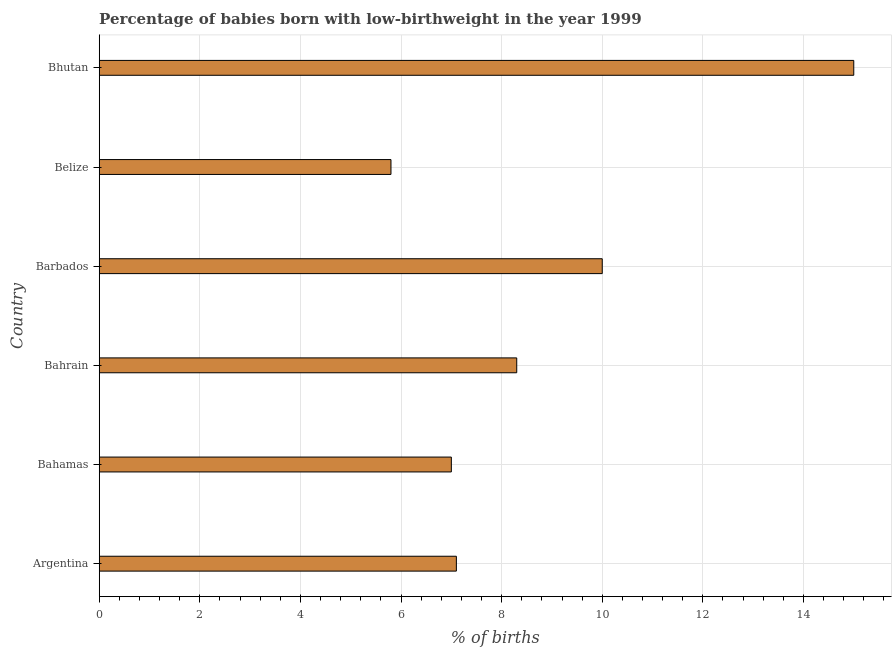Does the graph contain any zero values?
Make the answer very short. No. Does the graph contain grids?
Give a very brief answer. Yes. What is the title of the graph?
Make the answer very short. Percentage of babies born with low-birthweight in the year 1999. What is the label or title of the X-axis?
Offer a very short reply. % of births. What is the label or title of the Y-axis?
Make the answer very short. Country. Across all countries, what is the maximum percentage of babies who were born with low-birthweight?
Make the answer very short. 15. In which country was the percentage of babies who were born with low-birthweight maximum?
Offer a very short reply. Bhutan. In which country was the percentage of babies who were born with low-birthweight minimum?
Offer a terse response. Belize. What is the sum of the percentage of babies who were born with low-birthweight?
Your response must be concise. 53.2. What is the average percentage of babies who were born with low-birthweight per country?
Your answer should be very brief. 8.87. What is the median percentage of babies who were born with low-birthweight?
Make the answer very short. 7.7. In how many countries, is the percentage of babies who were born with low-birthweight greater than 10.4 %?
Your answer should be very brief. 1. What is the ratio of the percentage of babies who were born with low-birthweight in Argentina to that in Bhutan?
Offer a terse response. 0.47. Is the difference between the percentage of babies who were born with low-birthweight in Argentina and Barbados greater than the difference between any two countries?
Offer a very short reply. No. Is the sum of the percentage of babies who were born with low-birthweight in Belize and Bhutan greater than the maximum percentage of babies who were born with low-birthweight across all countries?
Your response must be concise. Yes. In how many countries, is the percentage of babies who were born with low-birthweight greater than the average percentage of babies who were born with low-birthweight taken over all countries?
Ensure brevity in your answer.  2. How many bars are there?
Keep it short and to the point. 6. What is the difference between two consecutive major ticks on the X-axis?
Make the answer very short. 2. Are the values on the major ticks of X-axis written in scientific E-notation?
Provide a succinct answer. No. What is the % of births of Bahamas?
Give a very brief answer. 7. What is the % of births of Bhutan?
Offer a terse response. 15. What is the difference between the % of births in Argentina and Bahamas?
Keep it short and to the point. 0.1. What is the difference between the % of births in Argentina and Bahrain?
Give a very brief answer. -1.2. What is the difference between the % of births in Argentina and Barbados?
Make the answer very short. -2.9. What is the difference between the % of births in Bahamas and Bahrain?
Offer a very short reply. -1.3. What is the difference between the % of births in Bahamas and Belize?
Provide a short and direct response. 1.2. What is the difference between the % of births in Bahamas and Bhutan?
Make the answer very short. -8. What is the difference between the % of births in Bahrain and Belize?
Offer a terse response. 2.5. What is the difference between the % of births in Bahrain and Bhutan?
Your response must be concise. -6.7. What is the difference between the % of births in Barbados and Belize?
Your answer should be very brief. 4.2. What is the ratio of the % of births in Argentina to that in Bahrain?
Ensure brevity in your answer.  0.85. What is the ratio of the % of births in Argentina to that in Barbados?
Offer a terse response. 0.71. What is the ratio of the % of births in Argentina to that in Belize?
Keep it short and to the point. 1.22. What is the ratio of the % of births in Argentina to that in Bhutan?
Offer a very short reply. 0.47. What is the ratio of the % of births in Bahamas to that in Bahrain?
Offer a very short reply. 0.84. What is the ratio of the % of births in Bahamas to that in Barbados?
Your response must be concise. 0.7. What is the ratio of the % of births in Bahamas to that in Belize?
Give a very brief answer. 1.21. What is the ratio of the % of births in Bahamas to that in Bhutan?
Offer a very short reply. 0.47. What is the ratio of the % of births in Bahrain to that in Barbados?
Your answer should be very brief. 0.83. What is the ratio of the % of births in Bahrain to that in Belize?
Keep it short and to the point. 1.43. What is the ratio of the % of births in Bahrain to that in Bhutan?
Keep it short and to the point. 0.55. What is the ratio of the % of births in Barbados to that in Belize?
Offer a terse response. 1.72. What is the ratio of the % of births in Barbados to that in Bhutan?
Give a very brief answer. 0.67. What is the ratio of the % of births in Belize to that in Bhutan?
Offer a very short reply. 0.39. 